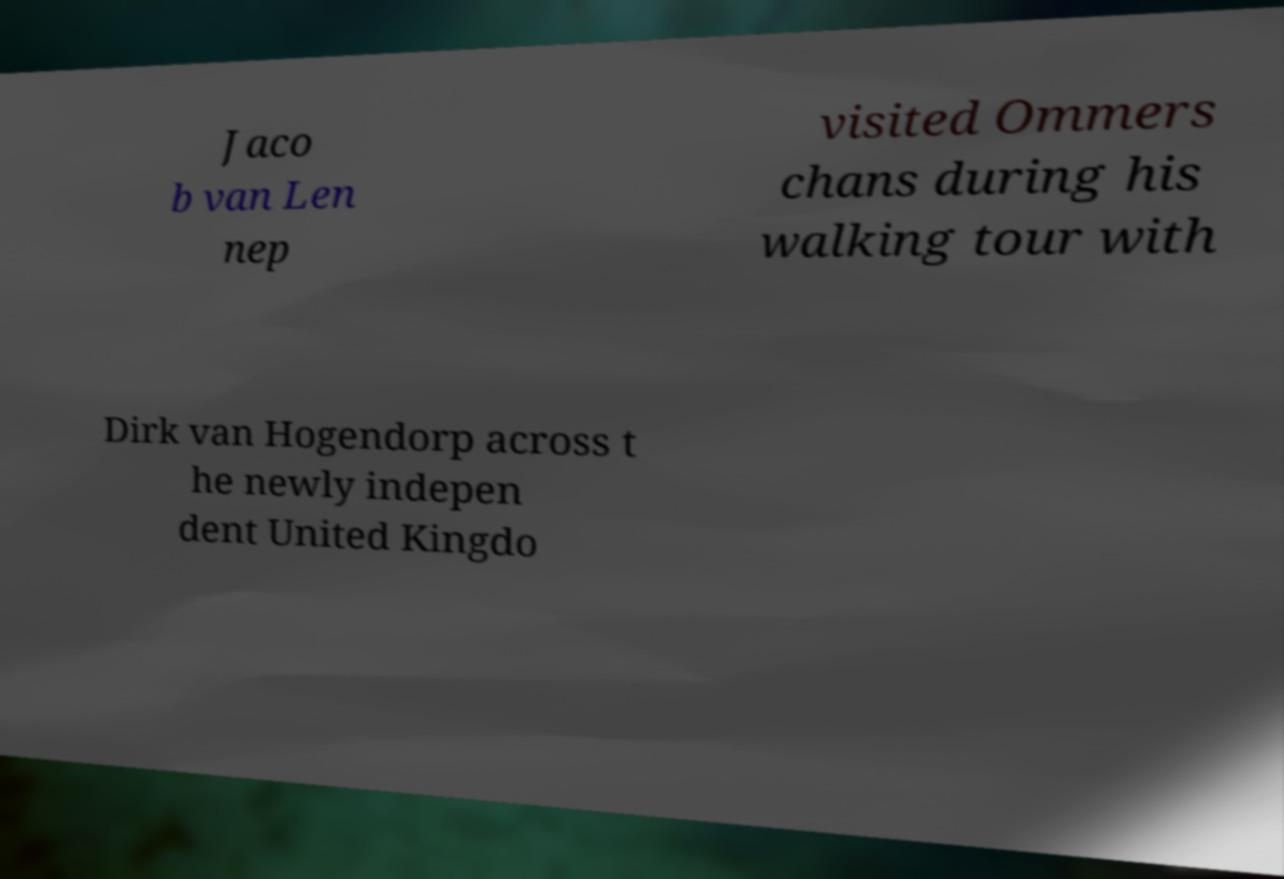What messages or text are displayed in this image? I need them in a readable, typed format. Jaco b van Len nep visited Ommers chans during his walking tour with Dirk van Hogendorp across t he newly indepen dent United Kingdo 